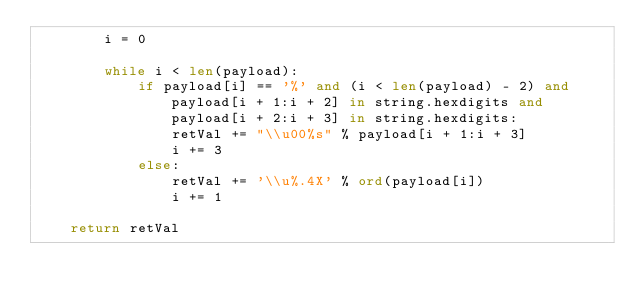<code> <loc_0><loc_0><loc_500><loc_500><_Python_>        i = 0

        while i < len(payload):
            if payload[i] == '%' and (i < len(payload) - 2) and payload[i + 1:i + 2] in string.hexdigits and payload[i + 2:i + 3] in string.hexdigits:
                retVal += "\\u00%s" % payload[i + 1:i + 3]
                i += 3
            else:
                retVal += '\\u%.4X' % ord(payload[i])
                i += 1

    return retVal
</code> 